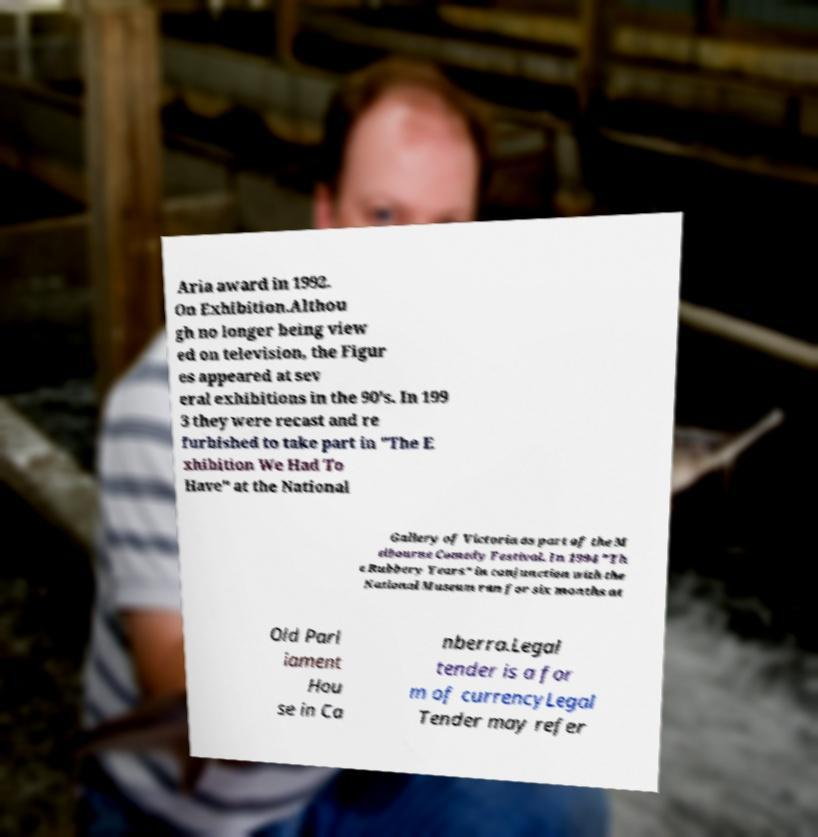Can you accurately transcribe the text from the provided image for me? Aria award in 1992. On Exhibition.Althou gh no longer being view ed on television, the Figur es appeared at sev eral exhibitions in the 90's. In 199 3 they were recast and re furbished to take part in "The E xhibition We Had To Have" at the National Gallery of Victoria as part of the M elbourne Comedy Festival. In 1994 "Th e Rubbery Years" in conjunction with the National Museum ran for six months at Old Parl iament Hou se in Ca nberra.Legal tender is a for m of currencyLegal Tender may refer 